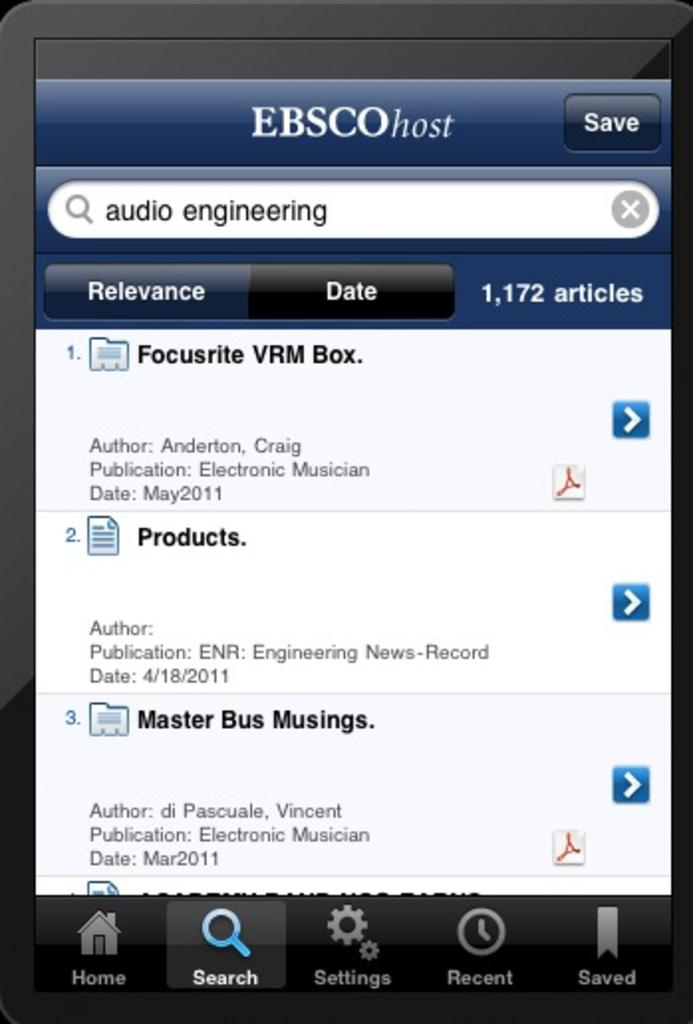<image>
Give a short and clear explanation of the subsequent image. A web page containing an Ebsco host page on display. 